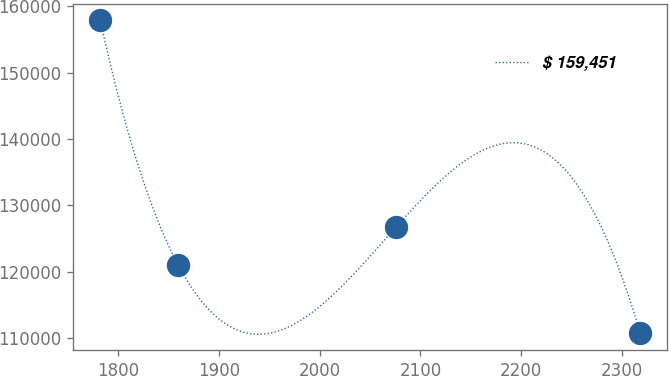Convert chart. <chart><loc_0><loc_0><loc_500><loc_500><line_chart><ecel><fcel>$ 159,451<nl><fcel>1782.5<fcel>157928<nl><fcel>1859.56<fcel>121099<nl><fcel>2076.09<fcel>126800<nl><fcel>2318.05<fcel>110714<nl></chart> 